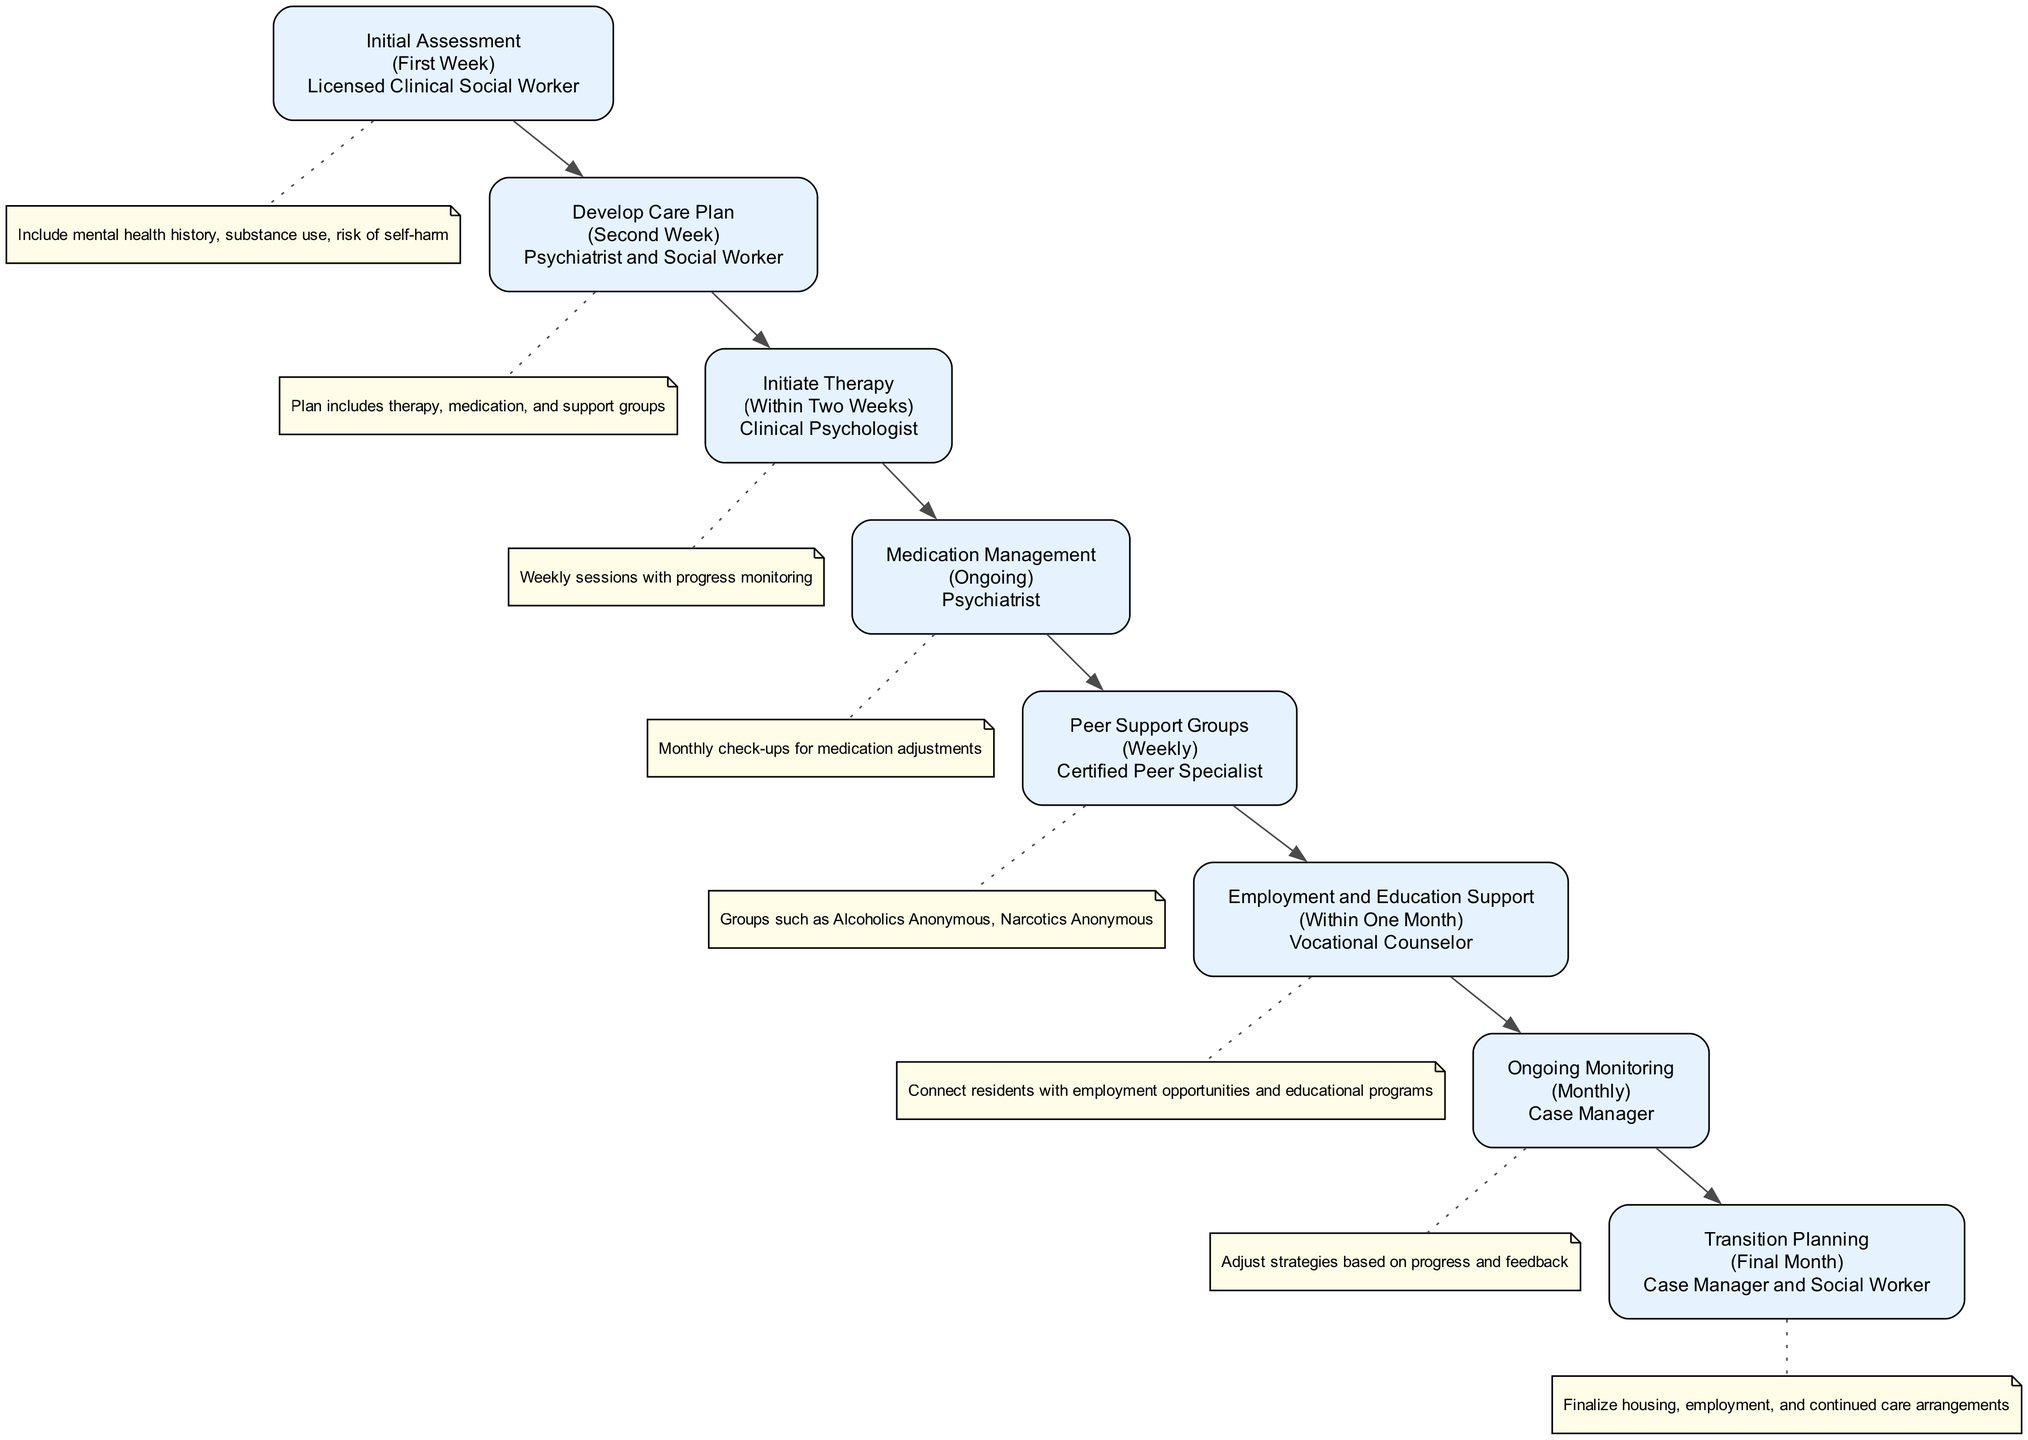What is the first stage of the pathway? The diagram starts with the "Initial Assessment" stage, which is the first element listed.
Answer: Initial Assessment Who is responsible for the ongoing medication management? The diagram states that a psychiatrist is responsible for the ongoing medication management stage.
Answer: Psychiatrist How long does it take to develop the care plan? The diagram indicates that the care plan is developed in the second week.
Answer: Second Week What stage follows the "Initiate Therapy" stage? By following the diagram flow, "Medication Management" comes after "Initiate Therapy."
Answer: Medication Management In which month does transition planning occur? According to the diagram, the transition planning happens during the final month, as stated in that stage.
Answer: Final Month How often are the peer support groups held? The diagram specifies that peer support groups are facilitated weekly.
Answer: Weekly What role does the vocational counselor play? The diagram assigns the vocational counselor the responsibility of providing job training and educational resources to residents.
Answer: Provide job training and educational resources Which two professionals are involved in transition planning? The diagram lists both the case manager and social worker as responsible for transition planning.
Answer: Case Manager and Social Worker How frequently is ongoing monitoring conducted? The diagram shows that ongoing monitoring occurs monthly to review and update care plans.
Answer: Monthly 